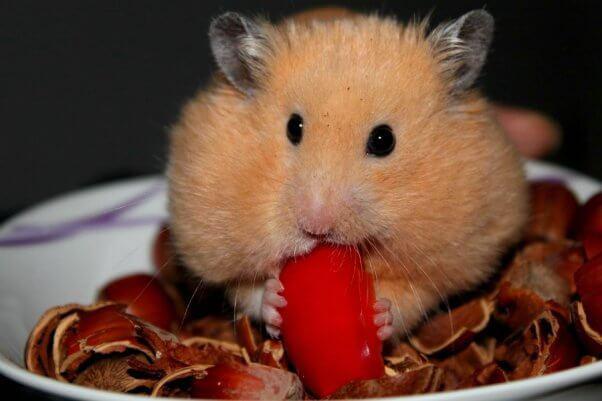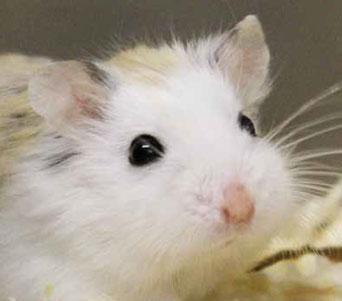The first image is the image on the left, the second image is the image on the right. Considering the images on both sides, is "A hamster is eating a piece of food." valid? Answer yes or no. Yes. 